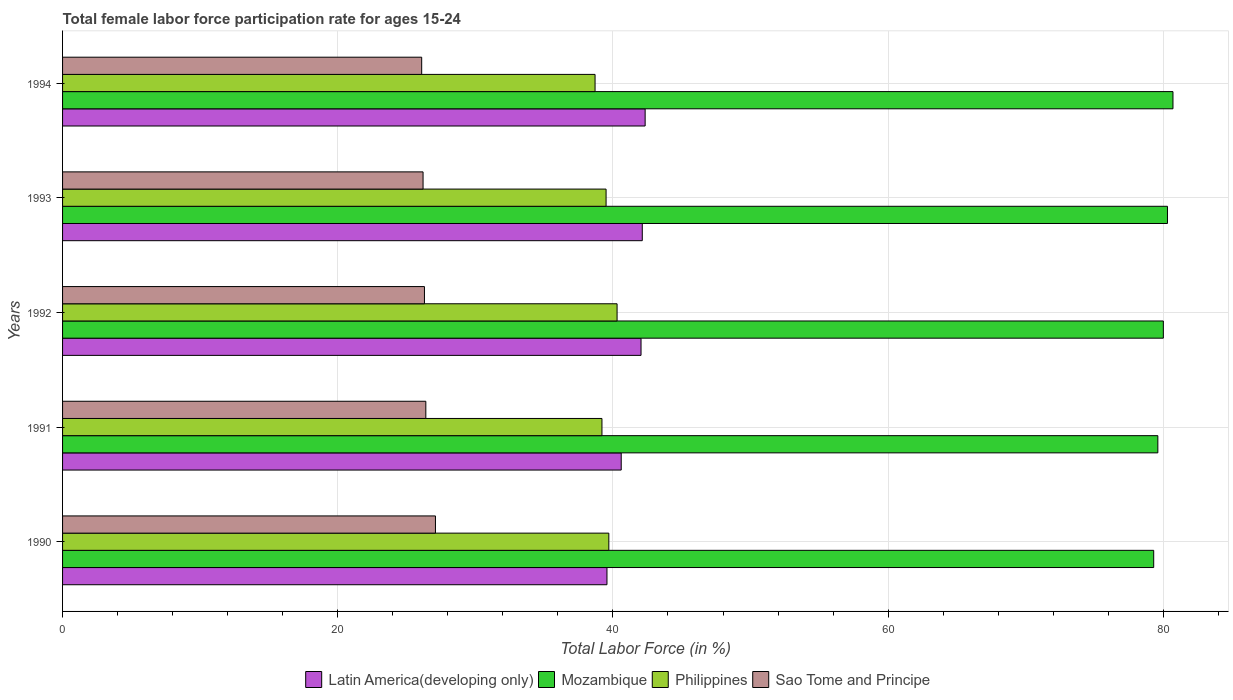How many different coloured bars are there?
Offer a terse response. 4. Are the number of bars per tick equal to the number of legend labels?
Provide a succinct answer. Yes. Are the number of bars on each tick of the Y-axis equal?
Your response must be concise. Yes. How many bars are there on the 2nd tick from the top?
Make the answer very short. 4. In how many cases, is the number of bars for a given year not equal to the number of legend labels?
Provide a short and direct response. 0. What is the female labor force participation rate in Sao Tome and Principe in 1993?
Provide a succinct answer. 26.2. Across all years, what is the maximum female labor force participation rate in Philippines?
Offer a very short reply. 40.3. Across all years, what is the minimum female labor force participation rate in Sao Tome and Principe?
Keep it short and to the point. 26.1. In which year was the female labor force participation rate in Latin America(developing only) minimum?
Offer a very short reply. 1990. What is the total female labor force participation rate in Latin America(developing only) in the graph?
Your response must be concise. 206.68. What is the difference between the female labor force participation rate in Latin America(developing only) in 1990 and that in 1994?
Give a very brief answer. -2.77. What is the difference between the female labor force participation rate in Sao Tome and Principe in 1990 and the female labor force participation rate in Latin America(developing only) in 1994?
Keep it short and to the point. -15.24. What is the average female labor force participation rate in Latin America(developing only) per year?
Offer a terse response. 41.34. In the year 1993, what is the difference between the female labor force participation rate in Philippines and female labor force participation rate in Latin America(developing only)?
Make the answer very short. -2.63. What is the ratio of the female labor force participation rate in Sao Tome and Principe in 1990 to that in 1992?
Offer a terse response. 1.03. What is the difference between the highest and the second highest female labor force participation rate in Philippines?
Keep it short and to the point. 0.6. What is the difference between the highest and the lowest female labor force participation rate in Philippines?
Ensure brevity in your answer.  1.6. Is the sum of the female labor force participation rate in Mozambique in 1992 and 1993 greater than the maximum female labor force participation rate in Sao Tome and Principe across all years?
Give a very brief answer. Yes. Is it the case that in every year, the sum of the female labor force participation rate in Latin America(developing only) and female labor force participation rate in Philippines is greater than the sum of female labor force participation rate in Mozambique and female labor force participation rate in Sao Tome and Principe?
Your answer should be compact. No. What does the 1st bar from the top in 1992 represents?
Keep it short and to the point. Sao Tome and Principe. What does the 4th bar from the bottom in 1990 represents?
Offer a very short reply. Sao Tome and Principe. How many bars are there?
Provide a short and direct response. 20. Are all the bars in the graph horizontal?
Offer a very short reply. Yes. Are the values on the major ticks of X-axis written in scientific E-notation?
Your answer should be very brief. No. How are the legend labels stacked?
Offer a terse response. Horizontal. What is the title of the graph?
Provide a short and direct response. Total female labor force participation rate for ages 15-24. What is the label or title of the X-axis?
Make the answer very short. Total Labor Force (in %). What is the label or title of the Y-axis?
Provide a short and direct response. Years. What is the Total Labor Force (in %) of Latin America(developing only) in 1990?
Provide a succinct answer. 39.57. What is the Total Labor Force (in %) of Mozambique in 1990?
Make the answer very short. 79.3. What is the Total Labor Force (in %) in Philippines in 1990?
Your answer should be compact. 39.7. What is the Total Labor Force (in %) in Sao Tome and Principe in 1990?
Ensure brevity in your answer.  27.1. What is the Total Labor Force (in %) of Latin America(developing only) in 1991?
Make the answer very short. 40.6. What is the Total Labor Force (in %) in Mozambique in 1991?
Provide a succinct answer. 79.6. What is the Total Labor Force (in %) of Philippines in 1991?
Provide a short and direct response. 39.2. What is the Total Labor Force (in %) in Sao Tome and Principe in 1991?
Make the answer very short. 26.4. What is the Total Labor Force (in %) of Latin America(developing only) in 1992?
Make the answer very short. 42.04. What is the Total Labor Force (in %) of Mozambique in 1992?
Keep it short and to the point. 80. What is the Total Labor Force (in %) of Philippines in 1992?
Your answer should be compact. 40.3. What is the Total Labor Force (in %) of Sao Tome and Principe in 1992?
Ensure brevity in your answer.  26.3. What is the Total Labor Force (in %) of Latin America(developing only) in 1993?
Ensure brevity in your answer.  42.13. What is the Total Labor Force (in %) of Mozambique in 1993?
Provide a succinct answer. 80.3. What is the Total Labor Force (in %) in Philippines in 1993?
Ensure brevity in your answer.  39.5. What is the Total Labor Force (in %) in Sao Tome and Principe in 1993?
Give a very brief answer. 26.2. What is the Total Labor Force (in %) in Latin America(developing only) in 1994?
Ensure brevity in your answer.  42.34. What is the Total Labor Force (in %) in Mozambique in 1994?
Provide a succinct answer. 80.7. What is the Total Labor Force (in %) of Philippines in 1994?
Provide a short and direct response. 38.7. What is the Total Labor Force (in %) in Sao Tome and Principe in 1994?
Provide a short and direct response. 26.1. Across all years, what is the maximum Total Labor Force (in %) of Latin America(developing only)?
Your answer should be compact. 42.34. Across all years, what is the maximum Total Labor Force (in %) in Mozambique?
Offer a very short reply. 80.7. Across all years, what is the maximum Total Labor Force (in %) in Philippines?
Keep it short and to the point. 40.3. Across all years, what is the maximum Total Labor Force (in %) in Sao Tome and Principe?
Your answer should be very brief. 27.1. Across all years, what is the minimum Total Labor Force (in %) in Latin America(developing only)?
Your answer should be very brief. 39.57. Across all years, what is the minimum Total Labor Force (in %) in Mozambique?
Your answer should be compact. 79.3. Across all years, what is the minimum Total Labor Force (in %) of Philippines?
Offer a terse response. 38.7. Across all years, what is the minimum Total Labor Force (in %) of Sao Tome and Principe?
Make the answer very short. 26.1. What is the total Total Labor Force (in %) in Latin America(developing only) in the graph?
Offer a terse response. 206.68. What is the total Total Labor Force (in %) of Mozambique in the graph?
Provide a succinct answer. 399.9. What is the total Total Labor Force (in %) in Philippines in the graph?
Provide a short and direct response. 197.4. What is the total Total Labor Force (in %) in Sao Tome and Principe in the graph?
Offer a very short reply. 132.1. What is the difference between the Total Labor Force (in %) in Latin America(developing only) in 1990 and that in 1991?
Your answer should be compact. -1.04. What is the difference between the Total Labor Force (in %) of Philippines in 1990 and that in 1991?
Provide a short and direct response. 0.5. What is the difference between the Total Labor Force (in %) in Sao Tome and Principe in 1990 and that in 1991?
Your answer should be very brief. 0.7. What is the difference between the Total Labor Force (in %) of Latin America(developing only) in 1990 and that in 1992?
Provide a short and direct response. -2.48. What is the difference between the Total Labor Force (in %) in Philippines in 1990 and that in 1992?
Ensure brevity in your answer.  -0.6. What is the difference between the Total Labor Force (in %) of Latin America(developing only) in 1990 and that in 1993?
Make the answer very short. -2.57. What is the difference between the Total Labor Force (in %) of Mozambique in 1990 and that in 1993?
Ensure brevity in your answer.  -1. What is the difference between the Total Labor Force (in %) of Philippines in 1990 and that in 1993?
Provide a short and direct response. 0.2. What is the difference between the Total Labor Force (in %) in Latin America(developing only) in 1990 and that in 1994?
Offer a very short reply. -2.77. What is the difference between the Total Labor Force (in %) in Mozambique in 1990 and that in 1994?
Your answer should be compact. -1.4. What is the difference between the Total Labor Force (in %) in Latin America(developing only) in 1991 and that in 1992?
Offer a terse response. -1.44. What is the difference between the Total Labor Force (in %) in Mozambique in 1991 and that in 1992?
Your answer should be very brief. -0.4. What is the difference between the Total Labor Force (in %) in Philippines in 1991 and that in 1992?
Your answer should be very brief. -1.1. What is the difference between the Total Labor Force (in %) in Latin America(developing only) in 1991 and that in 1993?
Keep it short and to the point. -1.53. What is the difference between the Total Labor Force (in %) in Sao Tome and Principe in 1991 and that in 1993?
Ensure brevity in your answer.  0.2. What is the difference between the Total Labor Force (in %) of Latin America(developing only) in 1991 and that in 1994?
Keep it short and to the point. -1.74. What is the difference between the Total Labor Force (in %) of Sao Tome and Principe in 1991 and that in 1994?
Your response must be concise. 0.3. What is the difference between the Total Labor Force (in %) of Latin America(developing only) in 1992 and that in 1993?
Your answer should be very brief. -0.09. What is the difference between the Total Labor Force (in %) in Mozambique in 1992 and that in 1993?
Your answer should be compact. -0.3. What is the difference between the Total Labor Force (in %) of Latin America(developing only) in 1992 and that in 1994?
Provide a succinct answer. -0.3. What is the difference between the Total Labor Force (in %) of Philippines in 1992 and that in 1994?
Your response must be concise. 1.6. What is the difference between the Total Labor Force (in %) of Sao Tome and Principe in 1992 and that in 1994?
Offer a very short reply. 0.2. What is the difference between the Total Labor Force (in %) in Latin America(developing only) in 1993 and that in 1994?
Provide a short and direct response. -0.21. What is the difference between the Total Labor Force (in %) of Philippines in 1993 and that in 1994?
Keep it short and to the point. 0.8. What is the difference between the Total Labor Force (in %) of Latin America(developing only) in 1990 and the Total Labor Force (in %) of Mozambique in 1991?
Ensure brevity in your answer.  -40.03. What is the difference between the Total Labor Force (in %) in Latin America(developing only) in 1990 and the Total Labor Force (in %) in Philippines in 1991?
Your answer should be compact. 0.37. What is the difference between the Total Labor Force (in %) in Latin America(developing only) in 1990 and the Total Labor Force (in %) in Sao Tome and Principe in 1991?
Offer a terse response. 13.17. What is the difference between the Total Labor Force (in %) in Mozambique in 1990 and the Total Labor Force (in %) in Philippines in 1991?
Your answer should be very brief. 40.1. What is the difference between the Total Labor Force (in %) of Mozambique in 1990 and the Total Labor Force (in %) of Sao Tome and Principe in 1991?
Give a very brief answer. 52.9. What is the difference between the Total Labor Force (in %) in Latin America(developing only) in 1990 and the Total Labor Force (in %) in Mozambique in 1992?
Make the answer very short. -40.43. What is the difference between the Total Labor Force (in %) in Latin America(developing only) in 1990 and the Total Labor Force (in %) in Philippines in 1992?
Provide a succinct answer. -0.73. What is the difference between the Total Labor Force (in %) in Latin America(developing only) in 1990 and the Total Labor Force (in %) in Sao Tome and Principe in 1992?
Offer a terse response. 13.27. What is the difference between the Total Labor Force (in %) of Mozambique in 1990 and the Total Labor Force (in %) of Philippines in 1992?
Give a very brief answer. 39. What is the difference between the Total Labor Force (in %) of Mozambique in 1990 and the Total Labor Force (in %) of Sao Tome and Principe in 1992?
Offer a terse response. 53. What is the difference between the Total Labor Force (in %) of Philippines in 1990 and the Total Labor Force (in %) of Sao Tome and Principe in 1992?
Offer a terse response. 13.4. What is the difference between the Total Labor Force (in %) in Latin America(developing only) in 1990 and the Total Labor Force (in %) in Mozambique in 1993?
Offer a terse response. -40.73. What is the difference between the Total Labor Force (in %) in Latin America(developing only) in 1990 and the Total Labor Force (in %) in Philippines in 1993?
Your answer should be compact. 0.07. What is the difference between the Total Labor Force (in %) in Latin America(developing only) in 1990 and the Total Labor Force (in %) in Sao Tome and Principe in 1993?
Offer a very short reply. 13.37. What is the difference between the Total Labor Force (in %) of Mozambique in 1990 and the Total Labor Force (in %) of Philippines in 1993?
Your answer should be very brief. 39.8. What is the difference between the Total Labor Force (in %) of Mozambique in 1990 and the Total Labor Force (in %) of Sao Tome and Principe in 1993?
Ensure brevity in your answer.  53.1. What is the difference between the Total Labor Force (in %) in Philippines in 1990 and the Total Labor Force (in %) in Sao Tome and Principe in 1993?
Provide a succinct answer. 13.5. What is the difference between the Total Labor Force (in %) in Latin America(developing only) in 1990 and the Total Labor Force (in %) in Mozambique in 1994?
Your response must be concise. -41.13. What is the difference between the Total Labor Force (in %) in Latin America(developing only) in 1990 and the Total Labor Force (in %) in Philippines in 1994?
Provide a short and direct response. 0.87. What is the difference between the Total Labor Force (in %) of Latin America(developing only) in 1990 and the Total Labor Force (in %) of Sao Tome and Principe in 1994?
Ensure brevity in your answer.  13.47. What is the difference between the Total Labor Force (in %) of Mozambique in 1990 and the Total Labor Force (in %) of Philippines in 1994?
Your answer should be very brief. 40.6. What is the difference between the Total Labor Force (in %) in Mozambique in 1990 and the Total Labor Force (in %) in Sao Tome and Principe in 1994?
Your response must be concise. 53.2. What is the difference between the Total Labor Force (in %) of Latin America(developing only) in 1991 and the Total Labor Force (in %) of Mozambique in 1992?
Make the answer very short. -39.4. What is the difference between the Total Labor Force (in %) in Latin America(developing only) in 1991 and the Total Labor Force (in %) in Philippines in 1992?
Your answer should be very brief. 0.3. What is the difference between the Total Labor Force (in %) in Latin America(developing only) in 1991 and the Total Labor Force (in %) in Sao Tome and Principe in 1992?
Keep it short and to the point. 14.3. What is the difference between the Total Labor Force (in %) of Mozambique in 1991 and the Total Labor Force (in %) of Philippines in 1992?
Your answer should be very brief. 39.3. What is the difference between the Total Labor Force (in %) in Mozambique in 1991 and the Total Labor Force (in %) in Sao Tome and Principe in 1992?
Make the answer very short. 53.3. What is the difference between the Total Labor Force (in %) in Latin America(developing only) in 1991 and the Total Labor Force (in %) in Mozambique in 1993?
Provide a short and direct response. -39.7. What is the difference between the Total Labor Force (in %) of Latin America(developing only) in 1991 and the Total Labor Force (in %) of Philippines in 1993?
Give a very brief answer. 1.1. What is the difference between the Total Labor Force (in %) of Latin America(developing only) in 1991 and the Total Labor Force (in %) of Sao Tome and Principe in 1993?
Your answer should be very brief. 14.4. What is the difference between the Total Labor Force (in %) in Mozambique in 1991 and the Total Labor Force (in %) in Philippines in 1993?
Your answer should be compact. 40.1. What is the difference between the Total Labor Force (in %) of Mozambique in 1991 and the Total Labor Force (in %) of Sao Tome and Principe in 1993?
Keep it short and to the point. 53.4. What is the difference between the Total Labor Force (in %) of Philippines in 1991 and the Total Labor Force (in %) of Sao Tome and Principe in 1993?
Provide a succinct answer. 13. What is the difference between the Total Labor Force (in %) of Latin America(developing only) in 1991 and the Total Labor Force (in %) of Mozambique in 1994?
Your response must be concise. -40.1. What is the difference between the Total Labor Force (in %) in Latin America(developing only) in 1991 and the Total Labor Force (in %) in Philippines in 1994?
Your response must be concise. 1.9. What is the difference between the Total Labor Force (in %) in Latin America(developing only) in 1991 and the Total Labor Force (in %) in Sao Tome and Principe in 1994?
Your answer should be very brief. 14.5. What is the difference between the Total Labor Force (in %) of Mozambique in 1991 and the Total Labor Force (in %) of Philippines in 1994?
Ensure brevity in your answer.  40.9. What is the difference between the Total Labor Force (in %) of Mozambique in 1991 and the Total Labor Force (in %) of Sao Tome and Principe in 1994?
Keep it short and to the point. 53.5. What is the difference between the Total Labor Force (in %) in Philippines in 1991 and the Total Labor Force (in %) in Sao Tome and Principe in 1994?
Provide a succinct answer. 13.1. What is the difference between the Total Labor Force (in %) in Latin America(developing only) in 1992 and the Total Labor Force (in %) in Mozambique in 1993?
Your answer should be compact. -38.26. What is the difference between the Total Labor Force (in %) in Latin America(developing only) in 1992 and the Total Labor Force (in %) in Philippines in 1993?
Provide a short and direct response. 2.54. What is the difference between the Total Labor Force (in %) in Latin America(developing only) in 1992 and the Total Labor Force (in %) in Sao Tome and Principe in 1993?
Provide a short and direct response. 15.84. What is the difference between the Total Labor Force (in %) in Mozambique in 1992 and the Total Labor Force (in %) in Philippines in 1993?
Give a very brief answer. 40.5. What is the difference between the Total Labor Force (in %) of Mozambique in 1992 and the Total Labor Force (in %) of Sao Tome and Principe in 1993?
Offer a terse response. 53.8. What is the difference between the Total Labor Force (in %) of Latin America(developing only) in 1992 and the Total Labor Force (in %) of Mozambique in 1994?
Keep it short and to the point. -38.66. What is the difference between the Total Labor Force (in %) in Latin America(developing only) in 1992 and the Total Labor Force (in %) in Philippines in 1994?
Your answer should be very brief. 3.34. What is the difference between the Total Labor Force (in %) of Latin America(developing only) in 1992 and the Total Labor Force (in %) of Sao Tome and Principe in 1994?
Offer a terse response. 15.94. What is the difference between the Total Labor Force (in %) in Mozambique in 1992 and the Total Labor Force (in %) in Philippines in 1994?
Your answer should be very brief. 41.3. What is the difference between the Total Labor Force (in %) in Mozambique in 1992 and the Total Labor Force (in %) in Sao Tome and Principe in 1994?
Provide a short and direct response. 53.9. What is the difference between the Total Labor Force (in %) in Latin America(developing only) in 1993 and the Total Labor Force (in %) in Mozambique in 1994?
Your answer should be compact. -38.57. What is the difference between the Total Labor Force (in %) in Latin America(developing only) in 1993 and the Total Labor Force (in %) in Philippines in 1994?
Offer a terse response. 3.43. What is the difference between the Total Labor Force (in %) in Latin America(developing only) in 1993 and the Total Labor Force (in %) in Sao Tome and Principe in 1994?
Your answer should be compact. 16.03. What is the difference between the Total Labor Force (in %) of Mozambique in 1993 and the Total Labor Force (in %) of Philippines in 1994?
Keep it short and to the point. 41.6. What is the difference between the Total Labor Force (in %) in Mozambique in 1993 and the Total Labor Force (in %) in Sao Tome and Principe in 1994?
Offer a terse response. 54.2. What is the average Total Labor Force (in %) in Latin America(developing only) per year?
Your answer should be very brief. 41.34. What is the average Total Labor Force (in %) of Mozambique per year?
Your answer should be very brief. 79.98. What is the average Total Labor Force (in %) of Philippines per year?
Give a very brief answer. 39.48. What is the average Total Labor Force (in %) of Sao Tome and Principe per year?
Provide a succinct answer. 26.42. In the year 1990, what is the difference between the Total Labor Force (in %) of Latin America(developing only) and Total Labor Force (in %) of Mozambique?
Your answer should be very brief. -39.73. In the year 1990, what is the difference between the Total Labor Force (in %) of Latin America(developing only) and Total Labor Force (in %) of Philippines?
Your answer should be very brief. -0.13. In the year 1990, what is the difference between the Total Labor Force (in %) of Latin America(developing only) and Total Labor Force (in %) of Sao Tome and Principe?
Your response must be concise. 12.47. In the year 1990, what is the difference between the Total Labor Force (in %) in Mozambique and Total Labor Force (in %) in Philippines?
Your answer should be compact. 39.6. In the year 1990, what is the difference between the Total Labor Force (in %) in Mozambique and Total Labor Force (in %) in Sao Tome and Principe?
Provide a succinct answer. 52.2. In the year 1991, what is the difference between the Total Labor Force (in %) in Latin America(developing only) and Total Labor Force (in %) in Mozambique?
Offer a terse response. -39. In the year 1991, what is the difference between the Total Labor Force (in %) of Latin America(developing only) and Total Labor Force (in %) of Philippines?
Your answer should be very brief. 1.4. In the year 1991, what is the difference between the Total Labor Force (in %) of Latin America(developing only) and Total Labor Force (in %) of Sao Tome and Principe?
Your answer should be compact. 14.2. In the year 1991, what is the difference between the Total Labor Force (in %) in Mozambique and Total Labor Force (in %) in Philippines?
Keep it short and to the point. 40.4. In the year 1991, what is the difference between the Total Labor Force (in %) of Mozambique and Total Labor Force (in %) of Sao Tome and Principe?
Provide a short and direct response. 53.2. In the year 1991, what is the difference between the Total Labor Force (in %) in Philippines and Total Labor Force (in %) in Sao Tome and Principe?
Offer a very short reply. 12.8. In the year 1992, what is the difference between the Total Labor Force (in %) of Latin America(developing only) and Total Labor Force (in %) of Mozambique?
Your response must be concise. -37.96. In the year 1992, what is the difference between the Total Labor Force (in %) of Latin America(developing only) and Total Labor Force (in %) of Philippines?
Ensure brevity in your answer.  1.74. In the year 1992, what is the difference between the Total Labor Force (in %) of Latin America(developing only) and Total Labor Force (in %) of Sao Tome and Principe?
Your answer should be compact. 15.74. In the year 1992, what is the difference between the Total Labor Force (in %) of Mozambique and Total Labor Force (in %) of Philippines?
Ensure brevity in your answer.  39.7. In the year 1992, what is the difference between the Total Labor Force (in %) of Mozambique and Total Labor Force (in %) of Sao Tome and Principe?
Ensure brevity in your answer.  53.7. In the year 1993, what is the difference between the Total Labor Force (in %) of Latin America(developing only) and Total Labor Force (in %) of Mozambique?
Make the answer very short. -38.17. In the year 1993, what is the difference between the Total Labor Force (in %) of Latin America(developing only) and Total Labor Force (in %) of Philippines?
Provide a short and direct response. 2.63. In the year 1993, what is the difference between the Total Labor Force (in %) in Latin America(developing only) and Total Labor Force (in %) in Sao Tome and Principe?
Keep it short and to the point. 15.93. In the year 1993, what is the difference between the Total Labor Force (in %) of Mozambique and Total Labor Force (in %) of Philippines?
Offer a very short reply. 40.8. In the year 1993, what is the difference between the Total Labor Force (in %) of Mozambique and Total Labor Force (in %) of Sao Tome and Principe?
Give a very brief answer. 54.1. In the year 1994, what is the difference between the Total Labor Force (in %) in Latin America(developing only) and Total Labor Force (in %) in Mozambique?
Keep it short and to the point. -38.36. In the year 1994, what is the difference between the Total Labor Force (in %) of Latin America(developing only) and Total Labor Force (in %) of Philippines?
Ensure brevity in your answer.  3.64. In the year 1994, what is the difference between the Total Labor Force (in %) of Latin America(developing only) and Total Labor Force (in %) of Sao Tome and Principe?
Make the answer very short. 16.24. In the year 1994, what is the difference between the Total Labor Force (in %) of Mozambique and Total Labor Force (in %) of Philippines?
Provide a succinct answer. 42. In the year 1994, what is the difference between the Total Labor Force (in %) of Mozambique and Total Labor Force (in %) of Sao Tome and Principe?
Keep it short and to the point. 54.6. What is the ratio of the Total Labor Force (in %) of Latin America(developing only) in 1990 to that in 1991?
Offer a terse response. 0.97. What is the ratio of the Total Labor Force (in %) in Philippines in 1990 to that in 1991?
Ensure brevity in your answer.  1.01. What is the ratio of the Total Labor Force (in %) in Sao Tome and Principe in 1990 to that in 1991?
Keep it short and to the point. 1.03. What is the ratio of the Total Labor Force (in %) of Latin America(developing only) in 1990 to that in 1992?
Your answer should be very brief. 0.94. What is the ratio of the Total Labor Force (in %) of Mozambique in 1990 to that in 1992?
Provide a succinct answer. 0.99. What is the ratio of the Total Labor Force (in %) of Philippines in 1990 to that in 1992?
Keep it short and to the point. 0.99. What is the ratio of the Total Labor Force (in %) in Sao Tome and Principe in 1990 to that in 1992?
Your response must be concise. 1.03. What is the ratio of the Total Labor Force (in %) of Latin America(developing only) in 1990 to that in 1993?
Make the answer very short. 0.94. What is the ratio of the Total Labor Force (in %) of Mozambique in 1990 to that in 1993?
Give a very brief answer. 0.99. What is the ratio of the Total Labor Force (in %) of Philippines in 1990 to that in 1993?
Your answer should be compact. 1.01. What is the ratio of the Total Labor Force (in %) of Sao Tome and Principe in 1990 to that in 1993?
Keep it short and to the point. 1.03. What is the ratio of the Total Labor Force (in %) of Latin America(developing only) in 1990 to that in 1994?
Your answer should be compact. 0.93. What is the ratio of the Total Labor Force (in %) in Mozambique in 1990 to that in 1994?
Ensure brevity in your answer.  0.98. What is the ratio of the Total Labor Force (in %) in Philippines in 1990 to that in 1994?
Your answer should be compact. 1.03. What is the ratio of the Total Labor Force (in %) in Sao Tome and Principe in 1990 to that in 1994?
Give a very brief answer. 1.04. What is the ratio of the Total Labor Force (in %) in Latin America(developing only) in 1991 to that in 1992?
Your answer should be compact. 0.97. What is the ratio of the Total Labor Force (in %) in Philippines in 1991 to that in 1992?
Keep it short and to the point. 0.97. What is the ratio of the Total Labor Force (in %) in Sao Tome and Principe in 1991 to that in 1992?
Offer a terse response. 1. What is the ratio of the Total Labor Force (in %) in Latin America(developing only) in 1991 to that in 1993?
Offer a terse response. 0.96. What is the ratio of the Total Labor Force (in %) of Sao Tome and Principe in 1991 to that in 1993?
Make the answer very short. 1.01. What is the ratio of the Total Labor Force (in %) of Latin America(developing only) in 1991 to that in 1994?
Provide a succinct answer. 0.96. What is the ratio of the Total Labor Force (in %) of Mozambique in 1991 to that in 1994?
Your answer should be very brief. 0.99. What is the ratio of the Total Labor Force (in %) of Philippines in 1991 to that in 1994?
Provide a short and direct response. 1.01. What is the ratio of the Total Labor Force (in %) of Sao Tome and Principe in 1991 to that in 1994?
Provide a short and direct response. 1.01. What is the ratio of the Total Labor Force (in %) of Latin America(developing only) in 1992 to that in 1993?
Keep it short and to the point. 1. What is the ratio of the Total Labor Force (in %) in Philippines in 1992 to that in 1993?
Your answer should be very brief. 1.02. What is the ratio of the Total Labor Force (in %) in Sao Tome and Principe in 1992 to that in 1993?
Make the answer very short. 1. What is the ratio of the Total Labor Force (in %) of Mozambique in 1992 to that in 1994?
Give a very brief answer. 0.99. What is the ratio of the Total Labor Force (in %) in Philippines in 1992 to that in 1994?
Ensure brevity in your answer.  1.04. What is the ratio of the Total Labor Force (in %) in Sao Tome and Principe in 1992 to that in 1994?
Offer a terse response. 1.01. What is the ratio of the Total Labor Force (in %) of Latin America(developing only) in 1993 to that in 1994?
Your response must be concise. 1. What is the ratio of the Total Labor Force (in %) of Mozambique in 1993 to that in 1994?
Give a very brief answer. 0.99. What is the ratio of the Total Labor Force (in %) of Philippines in 1993 to that in 1994?
Offer a terse response. 1.02. What is the difference between the highest and the second highest Total Labor Force (in %) of Latin America(developing only)?
Offer a very short reply. 0.21. What is the difference between the highest and the second highest Total Labor Force (in %) of Sao Tome and Principe?
Your answer should be compact. 0.7. What is the difference between the highest and the lowest Total Labor Force (in %) in Latin America(developing only)?
Make the answer very short. 2.77. What is the difference between the highest and the lowest Total Labor Force (in %) in Mozambique?
Keep it short and to the point. 1.4. What is the difference between the highest and the lowest Total Labor Force (in %) in Philippines?
Your response must be concise. 1.6. What is the difference between the highest and the lowest Total Labor Force (in %) in Sao Tome and Principe?
Give a very brief answer. 1. 